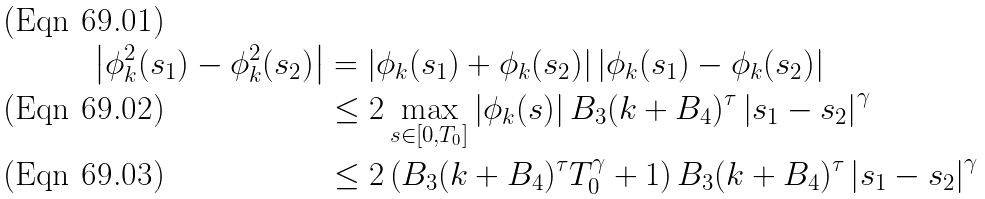<formula> <loc_0><loc_0><loc_500><loc_500>\left | \phi _ { k } ^ { 2 } ( s _ { 1 } ) - \phi _ { k } ^ { 2 } ( s _ { 2 } ) \right | & = \left | \phi _ { k } ( s _ { 1 } ) + \phi _ { k } ( s _ { 2 } ) \right | \left | \phi _ { k } ( s _ { 1 } ) - \phi _ { k } ( s _ { 2 } ) \right | \\ & \leq 2 \max _ { s \in [ 0 , T _ { 0 } ] } \left | \phi _ { k } ( s ) \right | B _ { 3 } ( k + B _ { 4 } ) ^ { \tau } \left | s _ { 1 } - s _ { 2 } \right | ^ { \gamma } \\ & \leq 2 \left ( B _ { 3 } ( k + B _ { 4 } ) ^ { \tau } T _ { 0 } ^ { \gamma } + 1 \right ) B _ { 3 } ( k + B _ { 4 } ) ^ { \tau } \left | s _ { 1 } - s _ { 2 } \right | ^ { \gamma }</formula> 